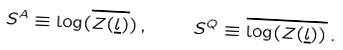Convert formula to latex. <formula><loc_0><loc_0><loc_500><loc_500>S ^ { A } \equiv \log ( \overline { Z ( \underline { l } ) } ) \, , \quad S ^ { Q } \equiv \overline { \log ( Z ( \underline { l } ) ) } \, .</formula> 